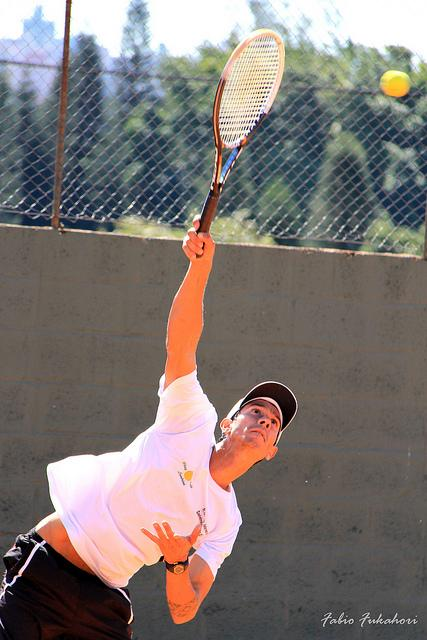What is his wrist accessory used for?

Choices:
A) administer insulin
B) measure speed
C) tell time
D) wipe sweat tell time 